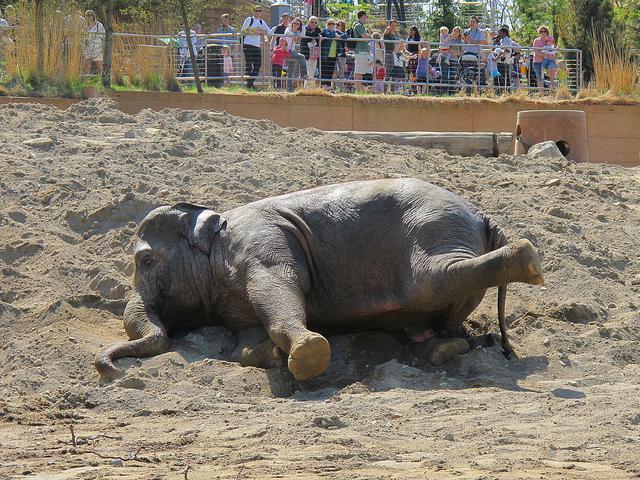How many elephants are there?
Give a very brief answer. 1. 